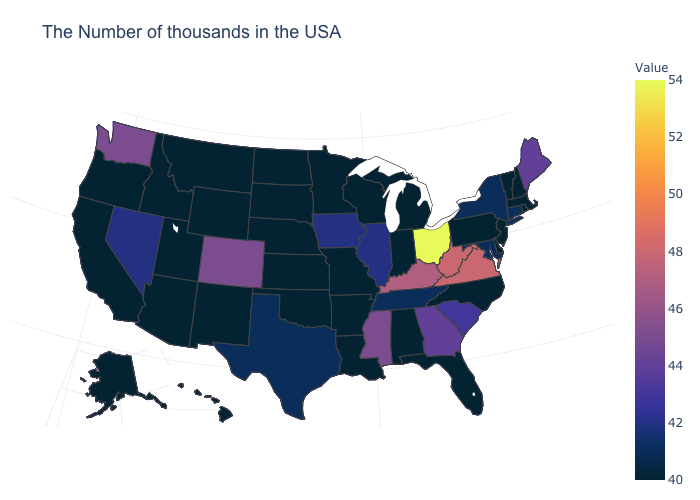Is the legend a continuous bar?
Quick response, please. Yes. Among the states that border Rhode Island , which have the highest value?
Quick response, please. Connecticut. Which states have the lowest value in the USA?
Quick response, please. Massachusetts, Rhode Island, New Hampshire, Vermont, New Jersey, Delaware, Pennsylvania, North Carolina, Florida, Michigan, Indiana, Alabama, Wisconsin, Louisiana, Missouri, Arkansas, Minnesota, Kansas, Nebraska, Oklahoma, South Dakota, North Dakota, Wyoming, New Mexico, Utah, Montana, Arizona, Idaho, California, Oregon, Alaska, Hawaii. Does the map have missing data?
Write a very short answer. No. 